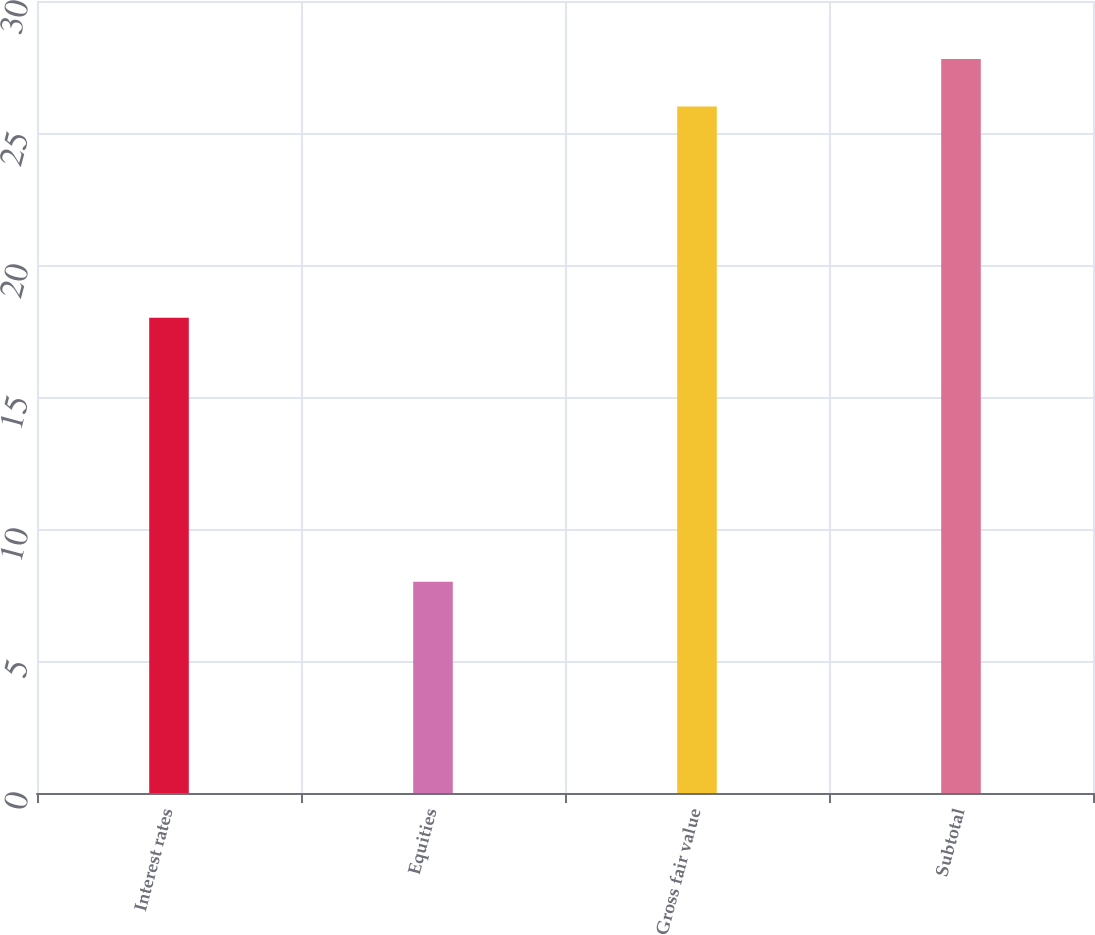Convert chart to OTSL. <chart><loc_0><loc_0><loc_500><loc_500><bar_chart><fcel>Interest rates<fcel>Equities<fcel>Gross fair value<fcel>Subtotal<nl><fcel>18<fcel>8<fcel>26<fcel>27.8<nl></chart> 